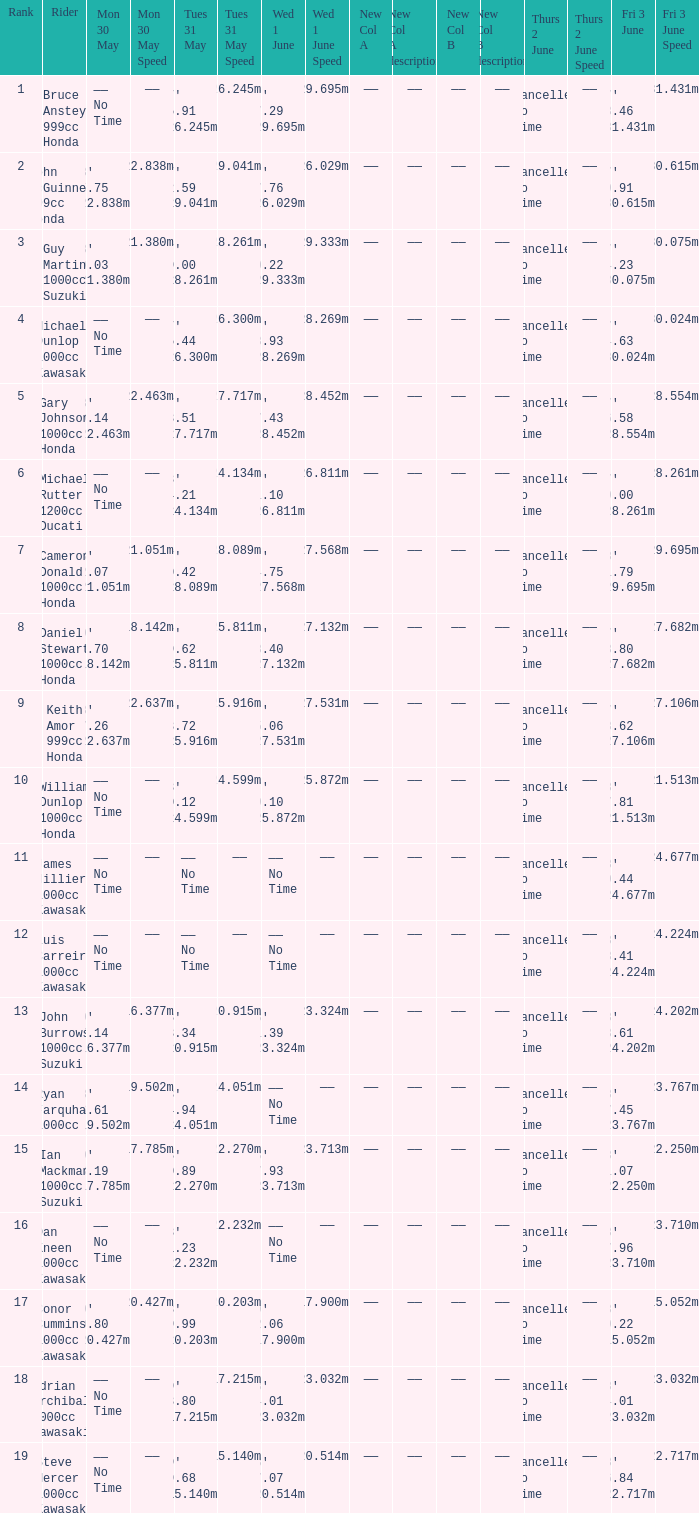What is the Mon 30 May time for the rider whose Fri 3 June time was 17' 13.46 131.431mph? —— No Time. 